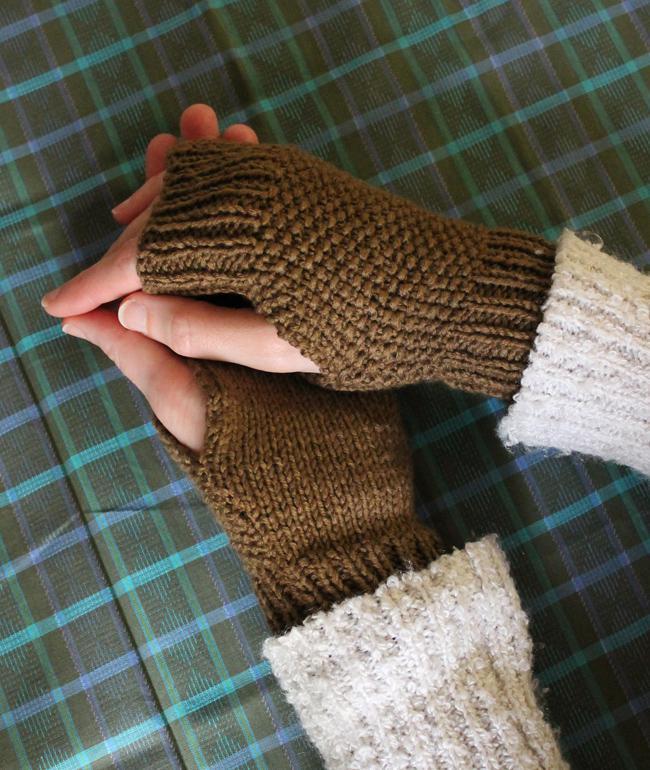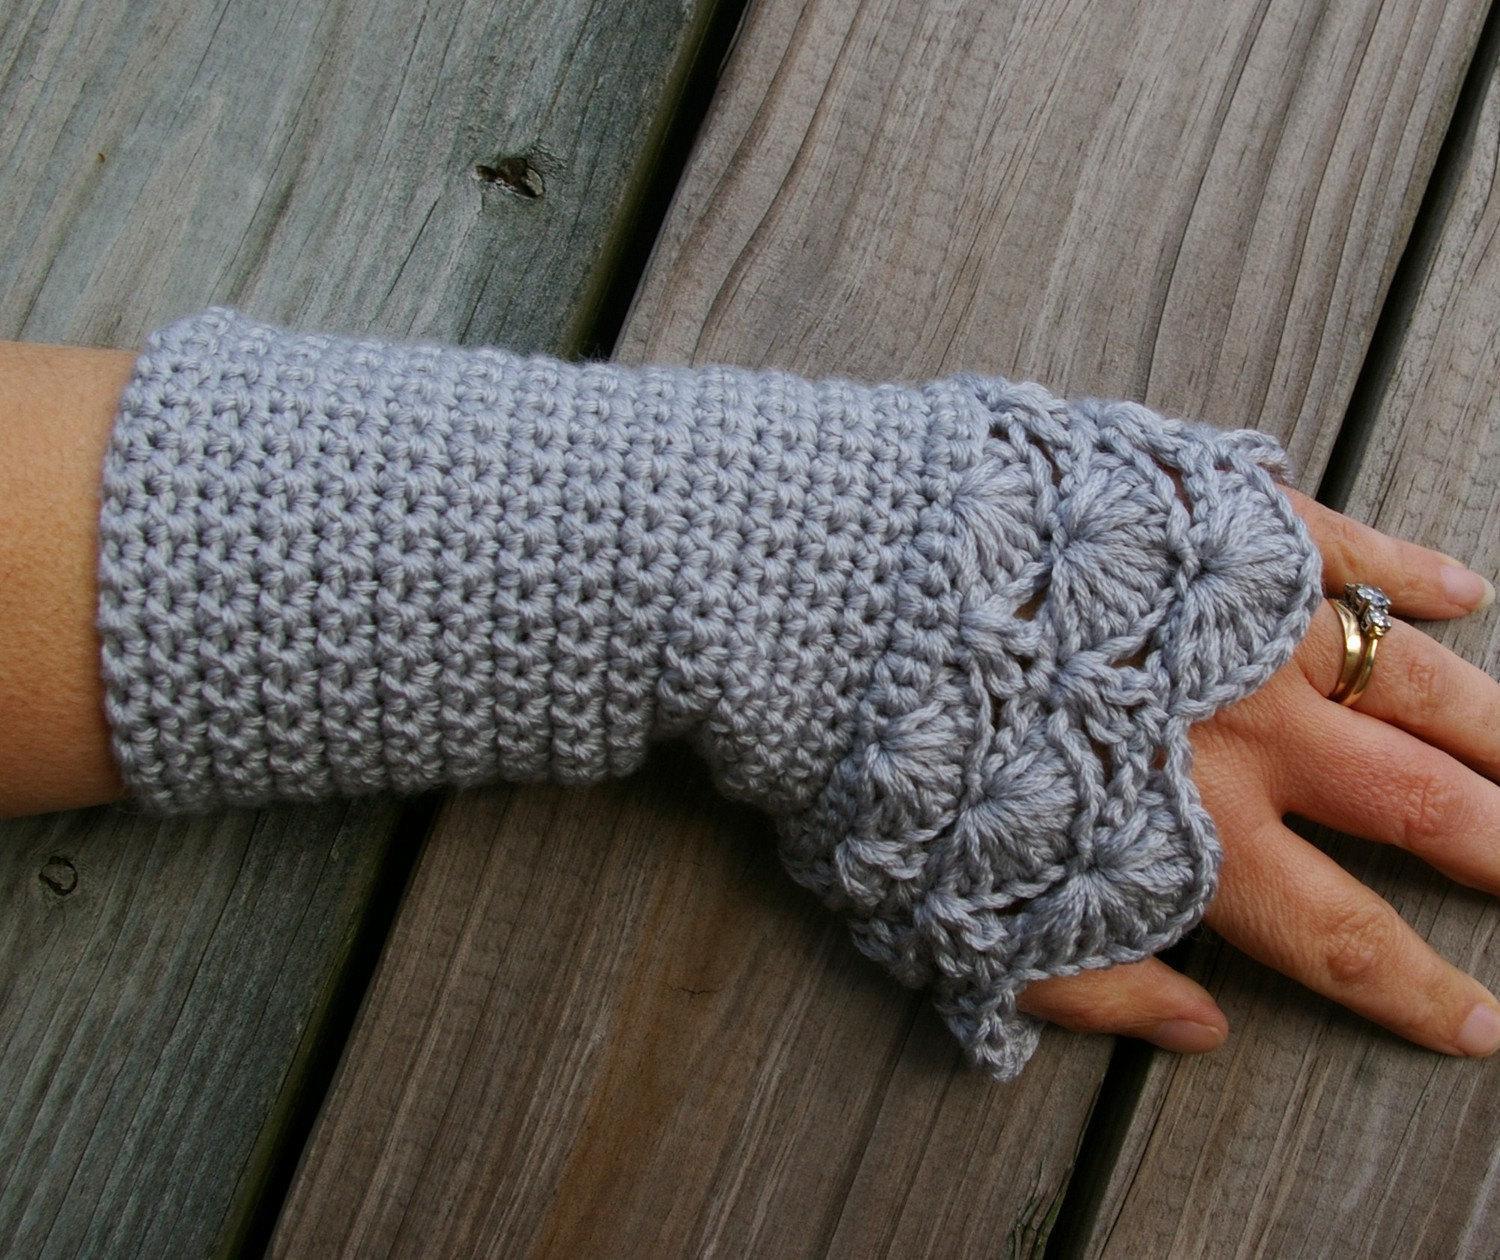The first image is the image on the left, the second image is the image on the right. For the images shown, is this caption "There is at least one human hand in the image on the right." true? Answer yes or no. Yes. 